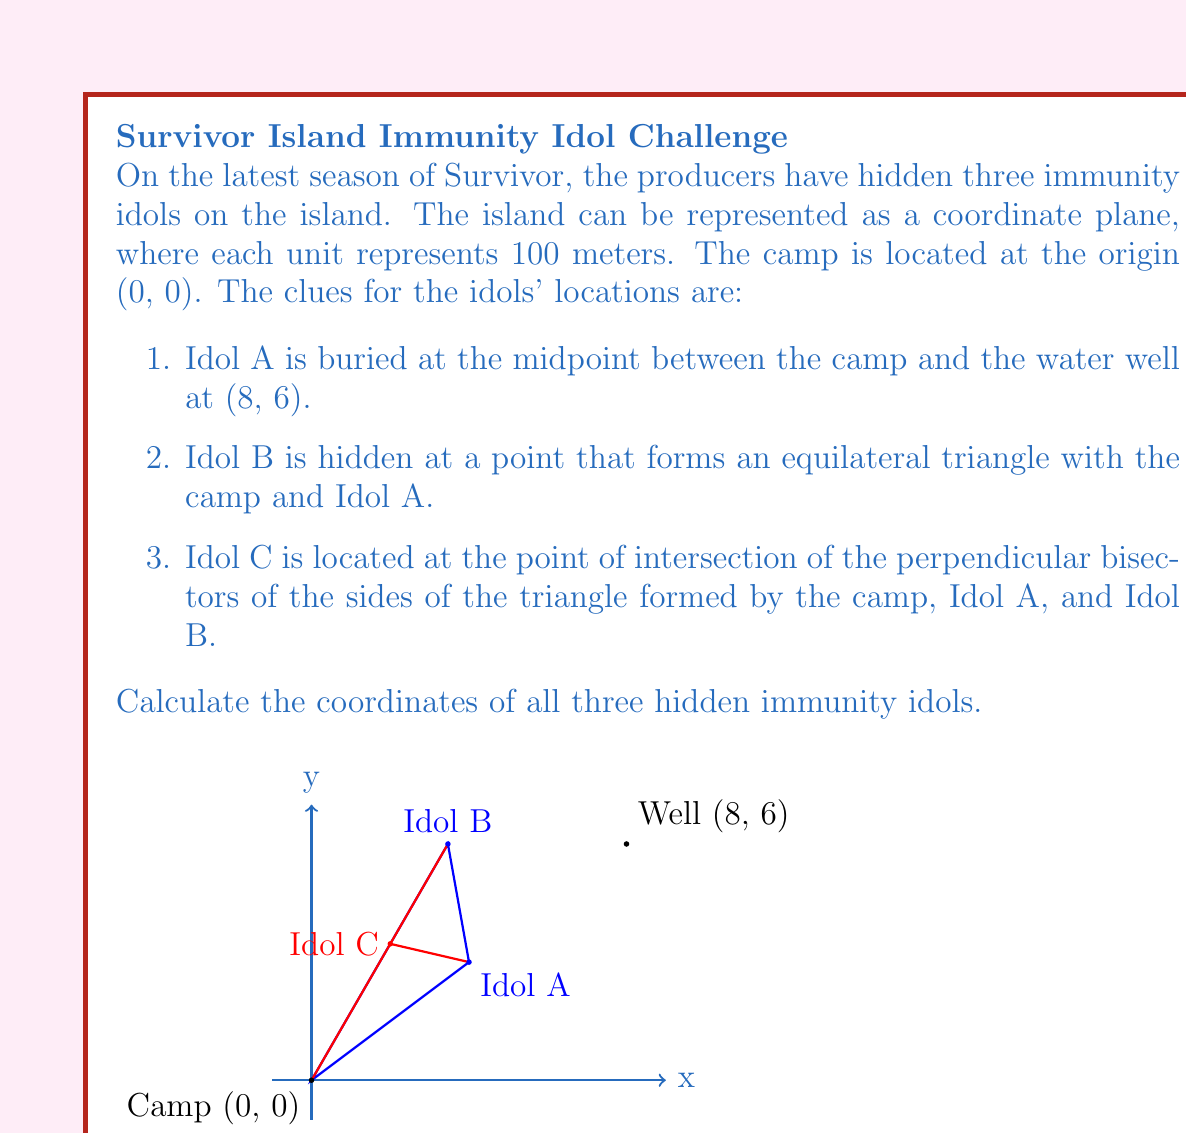Show me your answer to this math problem. Let's solve this step-by-step:

1. Coordinates of Idol A:
   The midpoint formula is $(\frac{x_1 + x_2}{2}, \frac{y_1 + y_2}{2})$
   $x = \frac{0 + 8}{2} = 4$, $y = \frac{0 + 6}{2} = 3$
   Idol A is at (4, 3)

2. Coordinates of Idol B:
   To form an equilateral triangle, Idol B must be 60° from the x-axis and the same distance from the camp as Idol A.
   Distance of Idol A from camp: $d = \sqrt{4^2 + 3^2} = 5$
   Angle from x-axis: $\theta = 60° = \frac{\pi}{3}$ radians
   $x = 5 \cos(\frac{\pi}{3}) = 5 \cdot \frac{1}{2} = 2.5$
   $y = 5 \sin(\frac{\pi}{3}) = 5 \cdot \frac{\sqrt{3}}{2} = 2.5\sqrt{3}$
   Idol B is at $(2.5, 2.5\sqrt{3})$ or approximately (2.5, 4.33)

3. Coordinates of Idol C:
   The perpendicular bisectors of a triangle intersect at the circumcenter.
   For any triangle with vertices $(x_1, y_1)$, $(x_2, y_2)$, and $(x_3, y_3)$, the circumcenter is given by:
   
   $$x = \frac{(x_1^2 + y_1^2)(y_2 - y_3) + (x_2^2 + y_2^2)(y_3 - y_1) + (x_3^2 + y_3^2)(y_1 - y_2)}{2[x_1(y_2 - y_3) + x_2(y_3 - y_1) + x_3(y_1 - y_2)]}$$
   
   $$y = \frac{(x_1^2 + y_1^2)(x_3 - x_2) + (x_2^2 + y_2^2)(x_1 - x_3) + (x_3^2 + y_3^2)(x_2 - x_1)}{2[x_1(y_2 - y_3) + x_2(y_3 - y_1) + x_3(y_1 - y_2)]}$$

   Substituting the values:
   $(x_1, y_1) = (0, 0)$, $(x_2, y_2) = (4, 3)$, $(x_3, y_3) = (2.5, 2.5\sqrt{3})$
   
   After calculation:
   $x = 2$, $y = 2\sqrt{3}$

   Idol C is at $(2, 2\sqrt{3})$ or approximately (2, 3.46)
Answer: Idol A: (4, 3), Idol B: $(2.5, 2.5\sqrt{3})$, Idol C: $(2, 2\sqrt{3})$ 